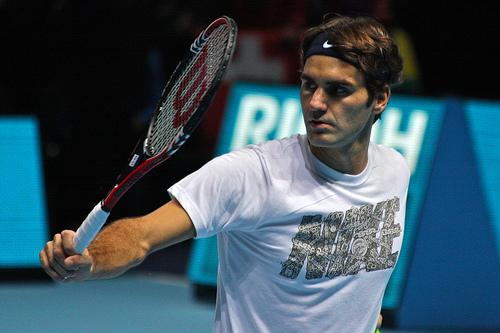Question: who is wearing a Nike shirt?
Choices:
A. The golfer.
B. The basketball player.
C. The tennis player.
D. The football player.
Answer with the letter. Answer: C Question: how many people are there?
Choices:
A. Two.
B. One.
C. Three.
D. Six.
Answer with the letter. Answer: B Question: what color is the tennis racket?
Choices:
A. White.
B. Black.
C. Green and blue.
D. Red and black.
Answer with the letter. Answer: D Question: what color is the man's shirt?
Choices:
A. Blue.
B. Black and white.
C. Red.
D. Pink.
Answer with the letter. Answer: B Question: what is in the man's hand?
Choices:
A. A ski pole.
B. A tennis racket.
C. A badminton racket.
D. A jai alai racquet.
Answer with the letter. Answer: B 